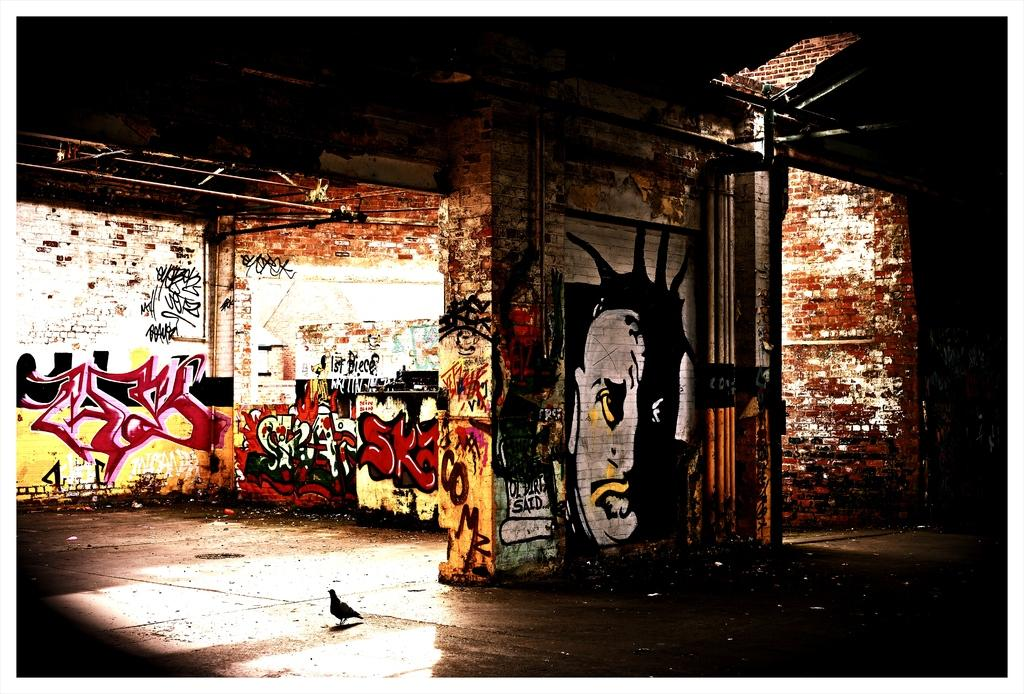What type of walls are depicted in the image? There are brick walls in the image. What is featured on the brick walls? The brick walls have paintings of text and images. What animal can be seen on the floor in the image? There is a bird on the floor in the image. What is located on the top of the wall in the image? There is a rod on the top of the wall in the image. Who is the creator of the bird in the image? There is no information about the creator of the bird in the image, as it is a photograph and not a work of art. 